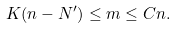Convert formula to latex. <formula><loc_0><loc_0><loc_500><loc_500>K ( n - N ^ { \prime } ) \leq m \leq C n .</formula> 